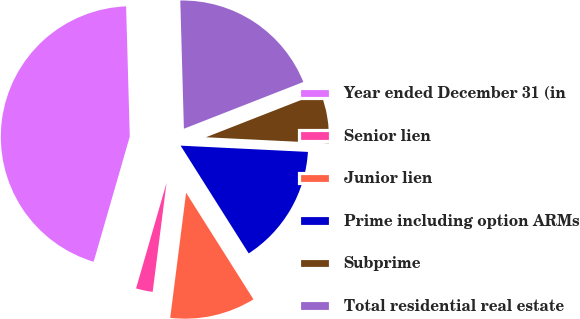Convert chart. <chart><loc_0><loc_0><loc_500><loc_500><pie_chart><fcel>Year ended December 31 (in<fcel>Senior lien<fcel>Junior lien<fcel>Prime including option ARMs<fcel>Subprime<fcel>Total residential real estate<nl><fcel>45.08%<fcel>2.46%<fcel>10.98%<fcel>15.25%<fcel>6.72%<fcel>19.51%<nl></chart> 